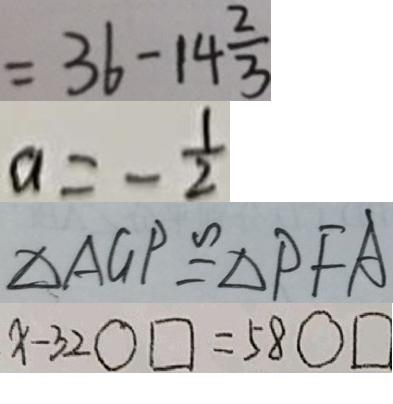<formula> <loc_0><loc_0><loc_500><loc_500>= 3 6 - 1 4 \frac { 2 } { 3 } 
 a = - \frac { 1 } { 2 } 
 \Delta A G P \cong \Delta P F A 
 x - 3 2 \bigcirc \square = 5 8 \bigcirc \square</formula> 